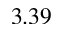<formula> <loc_0><loc_0><loc_500><loc_500>3 . 3 9</formula> 